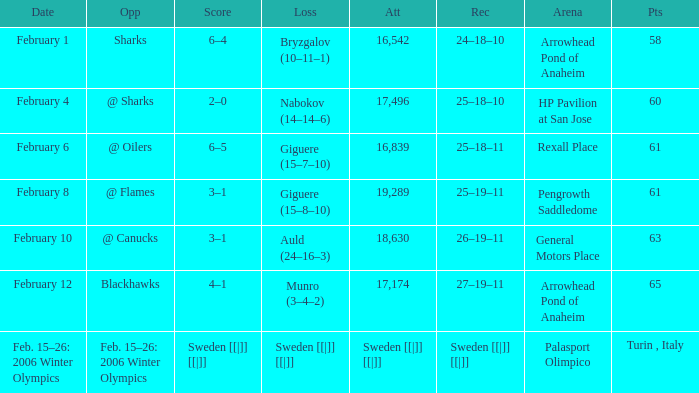What were the points on February 10? 63.0. 